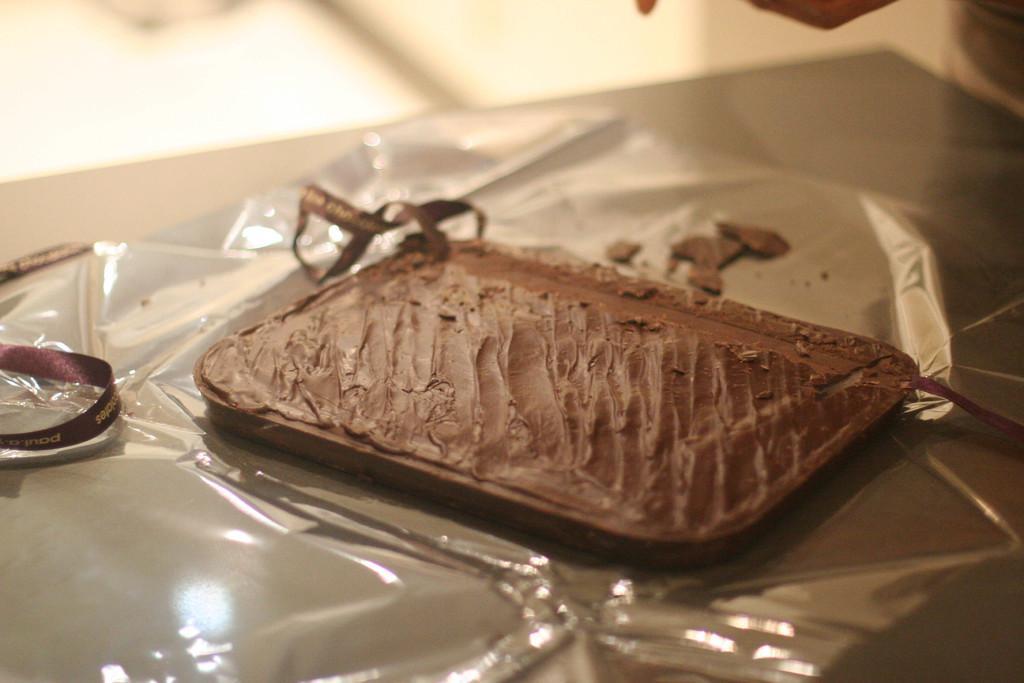How would you summarize this image in a sentence or two? In this image we can see a food item on the cover which is on the table. Beside the food item there are ribbons. 